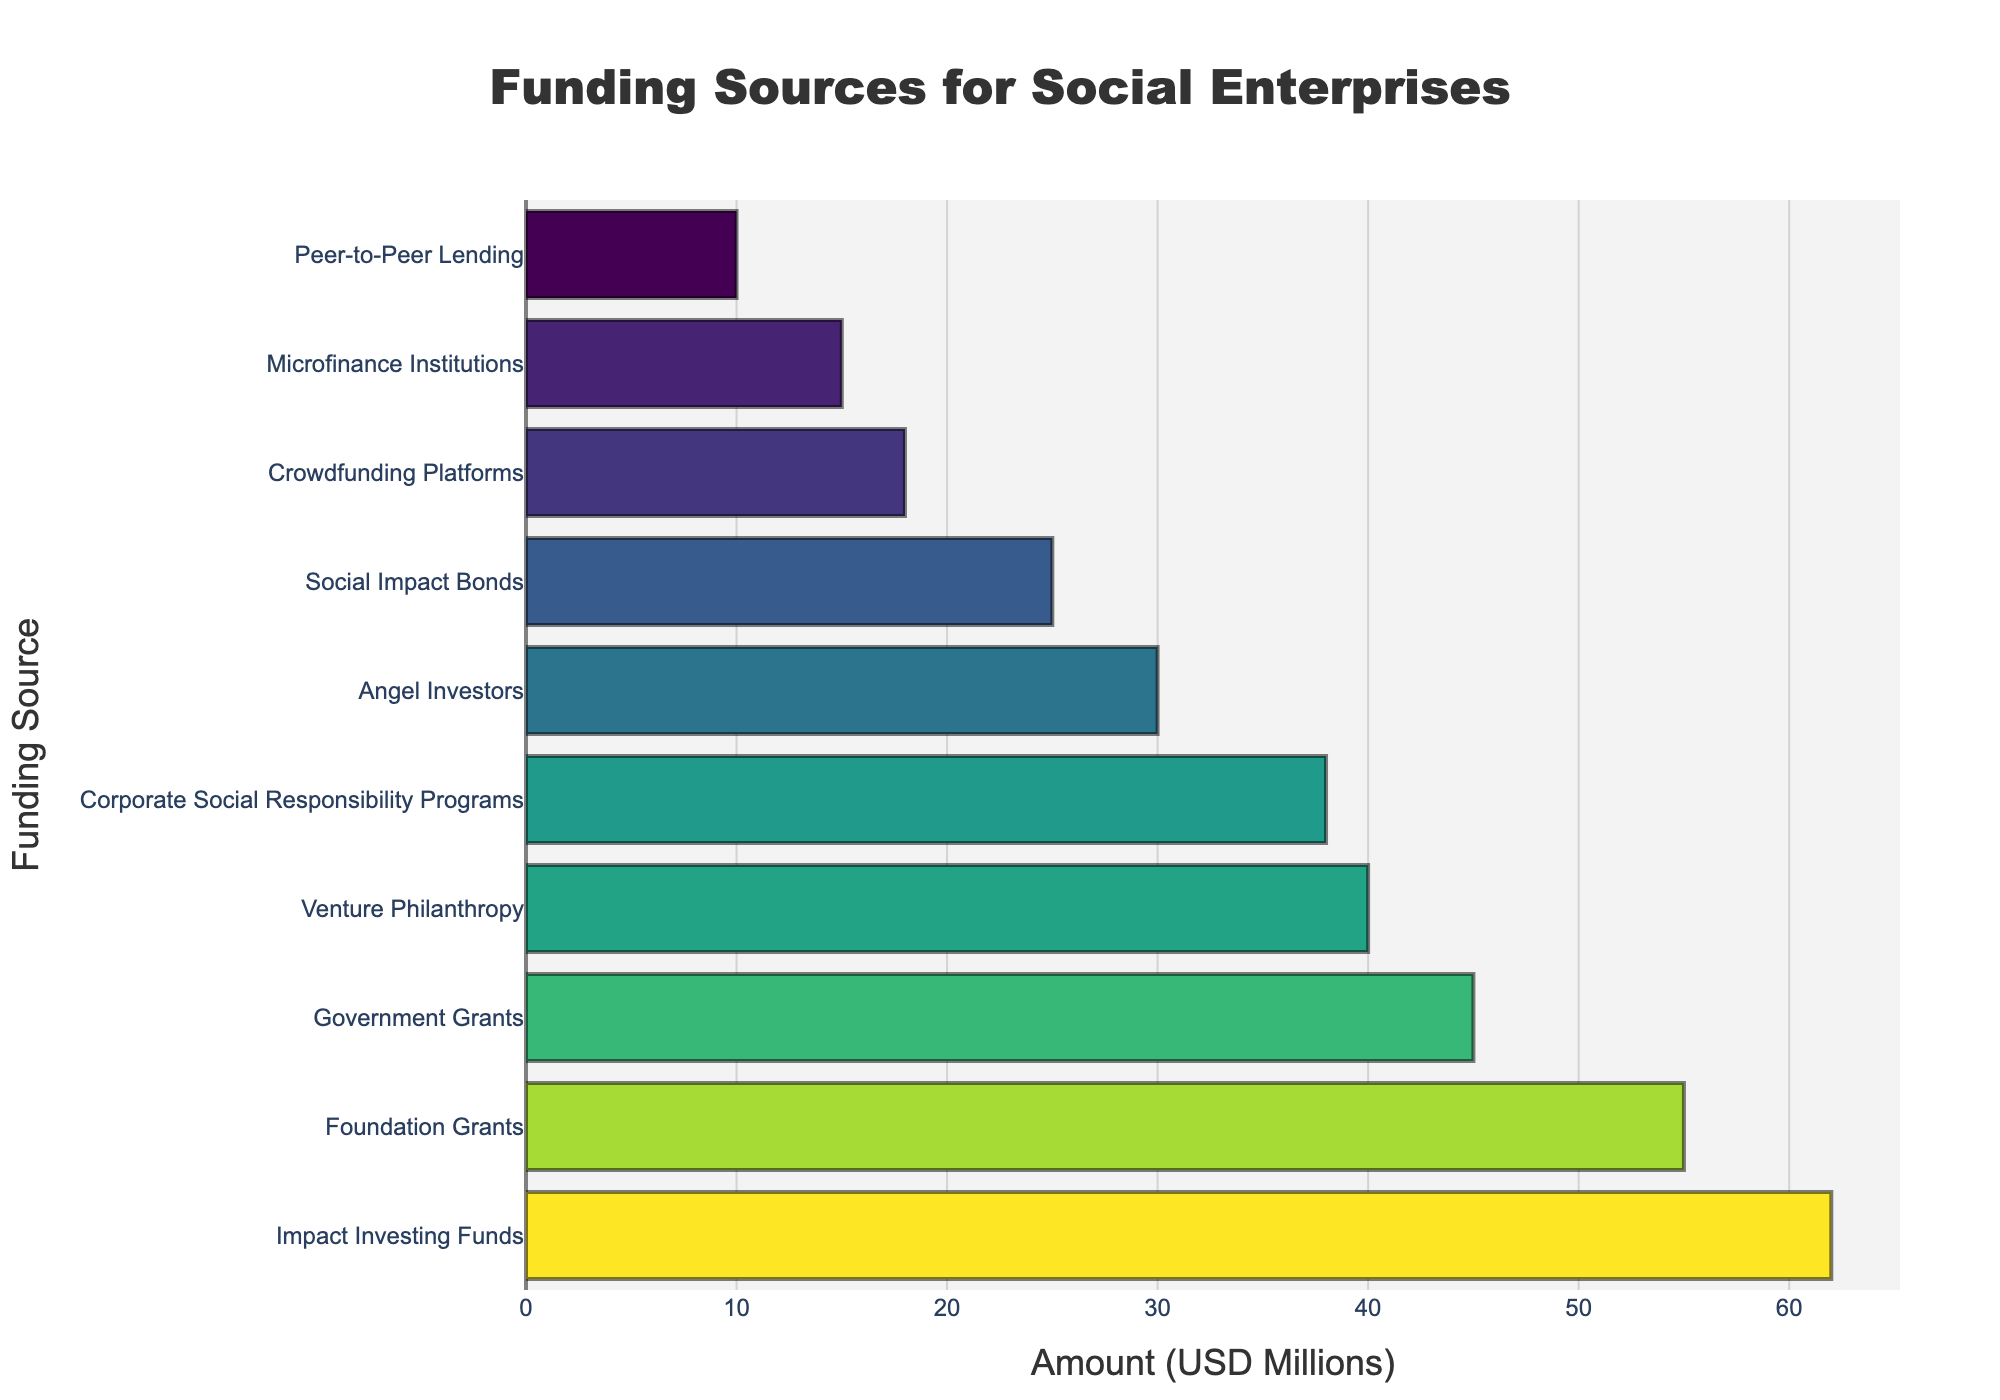What is the highest funding source for social enterprises? The highest funding source can be determined by the longest bar in the chart. In this case, "Impact Investing Funds" has the longest bar, indicating the largest amount of funding.
Answer: Impact Investing Funds Which funding source has the lowest amount? The lowest funding source corresponds to the shortest bar on the chart. "Peer-to-Peer Lending" has the shortest bar, signifying the smallest amount of funding.
Answer: Peer-to-Peer Lending How much more funding do Impact Investing Funds receive compared to Peer-to-Peer Lending? First, locate the bars for both "Impact Investing Funds" and "Peer-to-Peer Lending." The amount for "Impact Investing Funds" is 62 million USD, and for "Peer-to-Peer Lending," it is 10 million USD. Subtract the latter from the former: 62 - 10.
Answer: 52 million USD What is the total amount of funding provided by Government Grants, Foundation Grants, and Corporate Social Responsibility Programs? Find the amounts for each: Government Grants (45 million USD), Foundation Grants (55 million USD), and Corporate Social Responsibility Programs (38 million USD). Add these together: 45 + 55 + 38.
Answer: 138 million USD Which funding source is exactly in the middle when sorted by amount? First, sort all funding sources by amount. The middle value (median) in a dataset of ten entries is the 5th and 6th after sorting. The funding sources in the middle are Corporate Social Responsibility Programs (38 million USD) and Venture Philanthropy (40 million USD).
Answer: Corporate Social Responsibility Programs, Venture Philanthropy How much more funding does Foundation Grants receive compared to Angel Investors? Locate the bars for Foundation Grants (55 million USD) and Angel Investors (30 million USD). Subtract the amount of Angel Investors from Foundation Grants: 55 - 30.
Answer: 25 million USD What is the combined amount of funding provided by the top three sources? Identify the top three funding sources: Impact Investing Funds (62 million USD), Foundation Grants (55 million USD), and Government Grants (45 million USD). Sum these amounts: 62 + 55 + 45.
Answer: 162 million USD Which funding source receives more funds: Social Impact Bonds or Microfinance Institutions? Compare the lengths of the bars for Social Impact Bonds (25 million USD) and Microfinance Institutions (15 million USD). The bar for Social Impact Bonds is longer.
Answer: Social Impact Bonds 